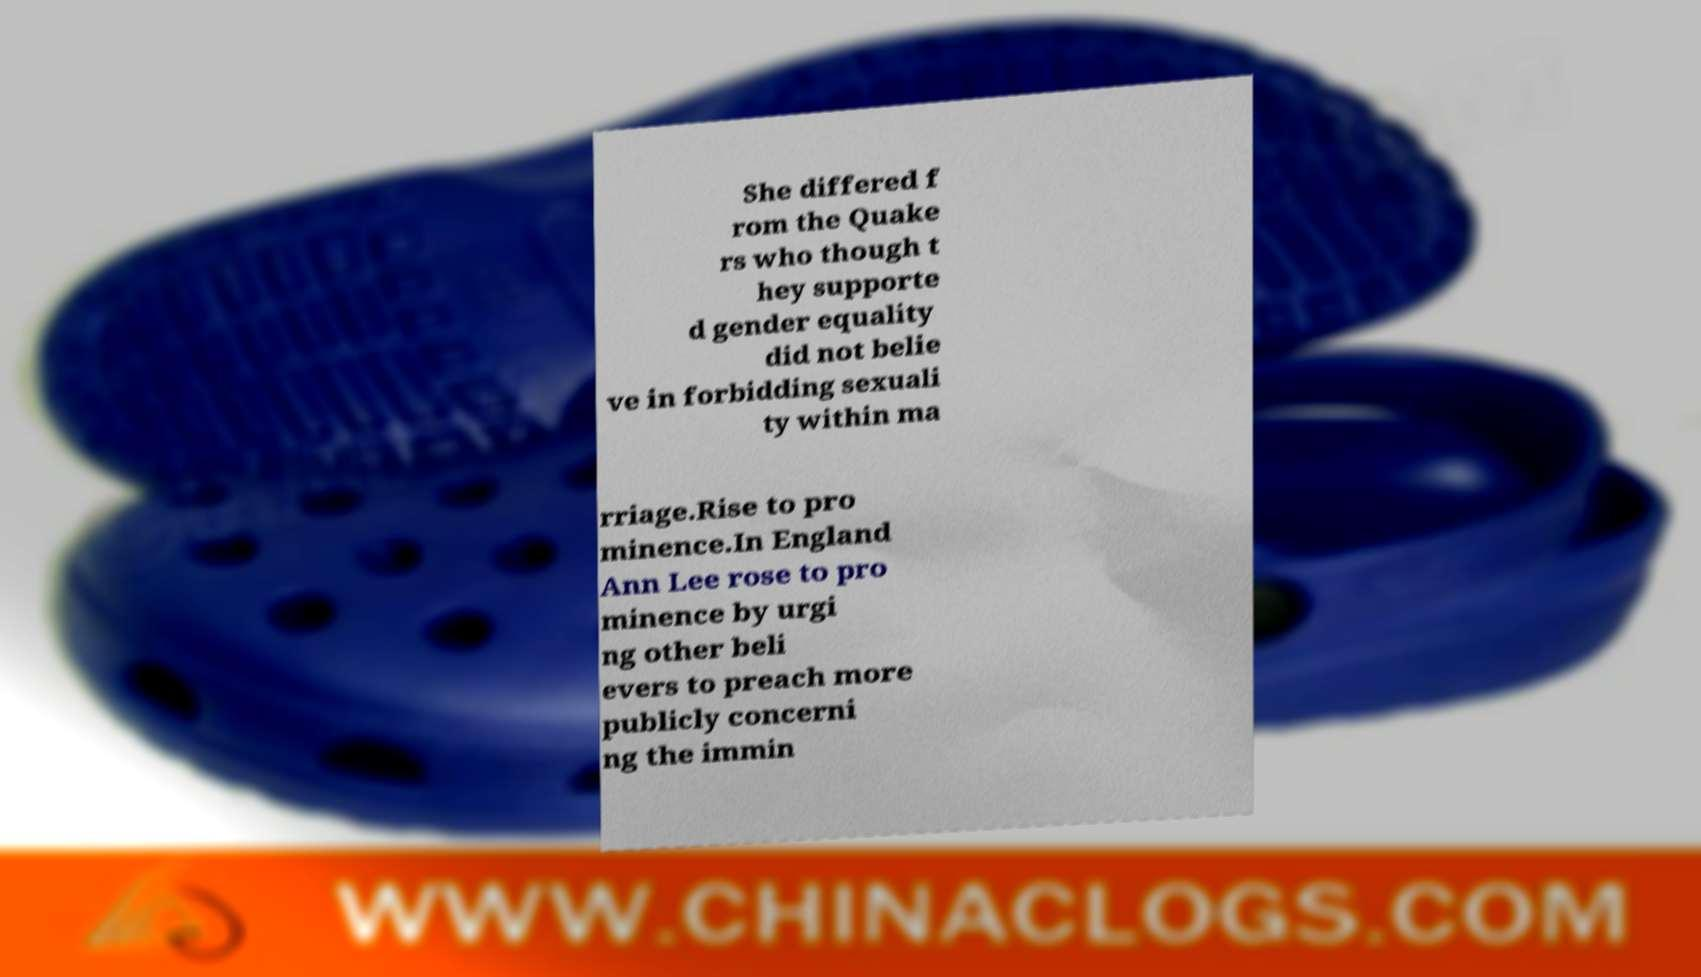What messages or text are displayed in this image? I need them in a readable, typed format. She differed f rom the Quake rs who though t hey supporte d gender equality did not belie ve in forbidding sexuali ty within ma rriage.Rise to pro minence.In England Ann Lee rose to pro minence by urgi ng other beli evers to preach more publicly concerni ng the immin 